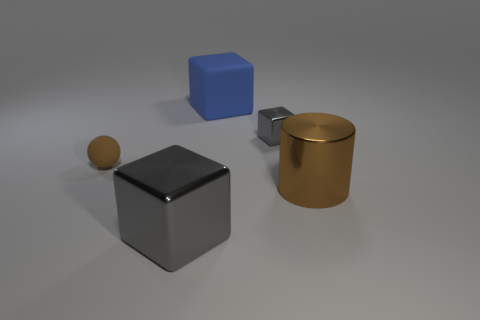Add 4 balls. How many objects exist? 9 Subtract all spheres. How many objects are left? 4 Add 4 large brown shiny cylinders. How many large brown shiny cylinders exist? 5 Subtract 1 gray blocks. How many objects are left? 4 Subtract all big brown objects. Subtract all large cylinders. How many objects are left? 3 Add 1 matte balls. How many matte balls are left? 2 